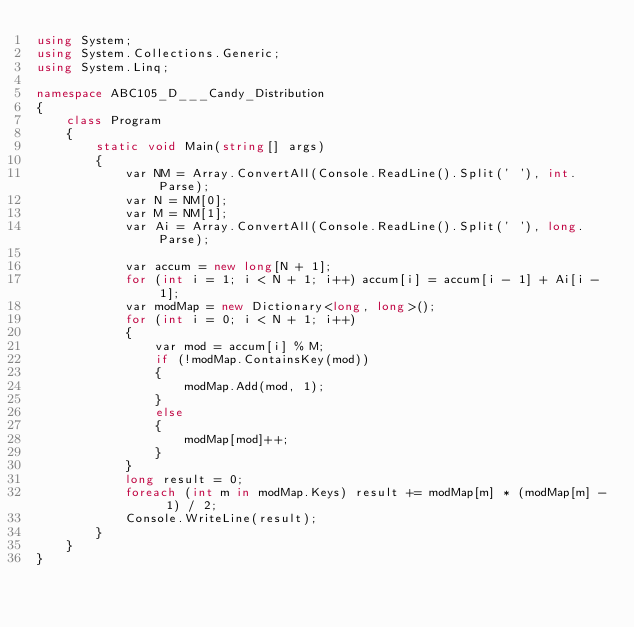<code> <loc_0><loc_0><loc_500><loc_500><_C#_>using System;
using System.Collections.Generic;
using System.Linq;

namespace ABC105_D___Candy_Distribution
{
    class Program
    {
        static void Main(string[] args)
        {
            var NM = Array.ConvertAll(Console.ReadLine().Split(' '), int.Parse);
            var N = NM[0];
            var M = NM[1];
            var Ai = Array.ConvertAll(Console.ReadLine().Split(' '), long.Parse);

            var accum = new long[N + 1];
            for (int i = 1; i < N + 1; i++) accum[i] = accum[i - 1] + Ai[i - 1];
            var modMap = new Dictionary<long, long>();
            for (int i = 0; i < N + 1; i++)
            {
                var mod = accum[i] % M;
                if (!modMap.ContainsKey(mod))
                {
                    modMap.Add(mod, 1);
                }
                else
                {
                    modMap[mod]++;
                }
            }
            long result = 0;
            foreach (int m in modMap.Keys) result += modMap[m] * (modMap[m] - 1) / 2;
            Console.WriteLine(result);
        }
    }
}
</code> 